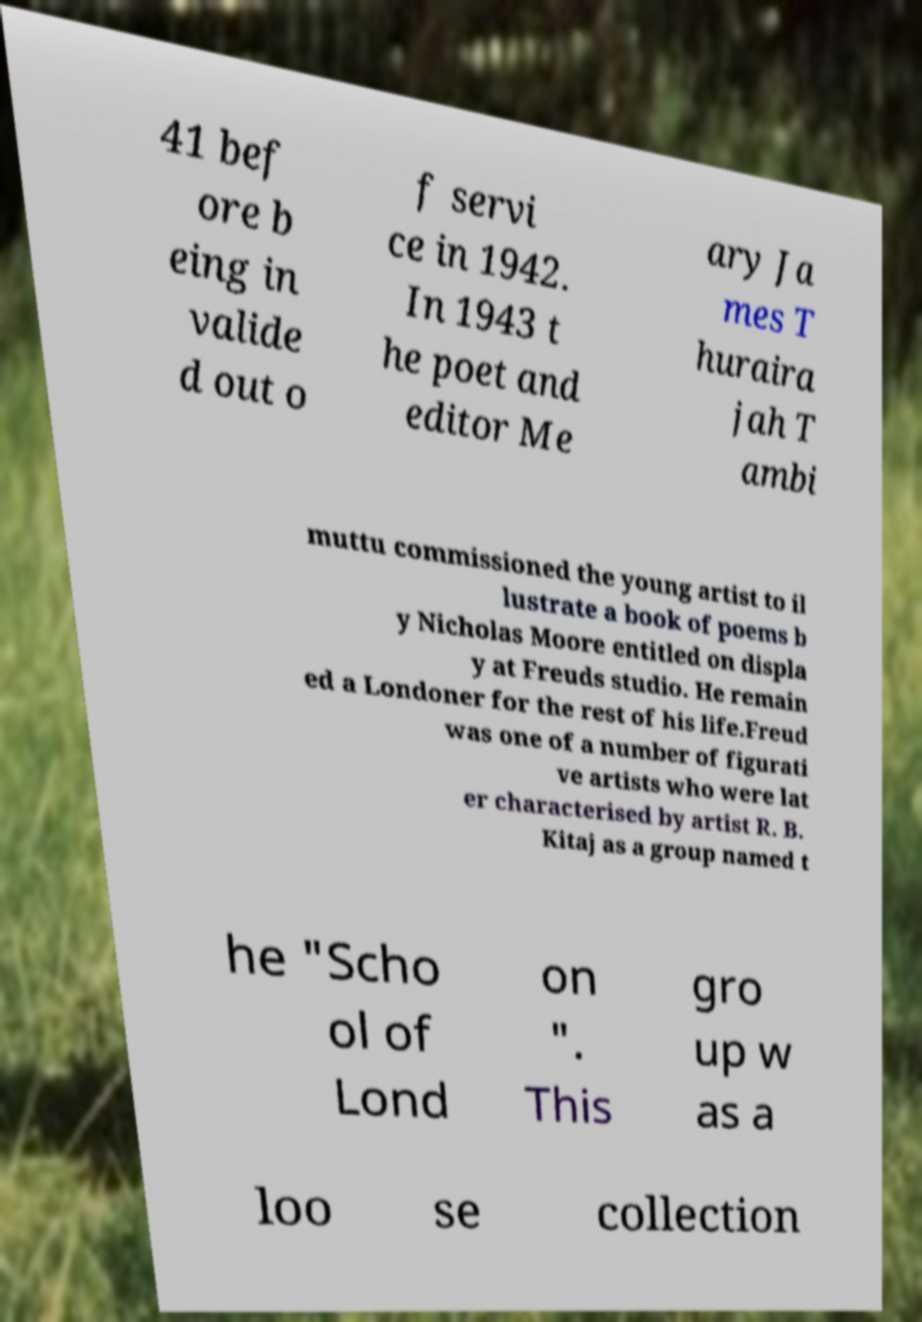Could you assist in decoding the text presented in this image and type it out clearly? 41 bef ore b eing in valide d out o f servi ce in 1942. In 1943 t he poet and editor Me ary Ja mes T huraira jah T ambi muttu commissioned the young artist to il lustrate a book of poems b y Nicholas Moore entitled on displa y at Freuds studio. He remain ed a Londoner for the rest of his life.Freud was one of a number of figurati ve artists who were lat er characterised by artist R. B. Kitaj as a group named t he "Scho ol of Lond on ". This gro up w as a loo se collection 